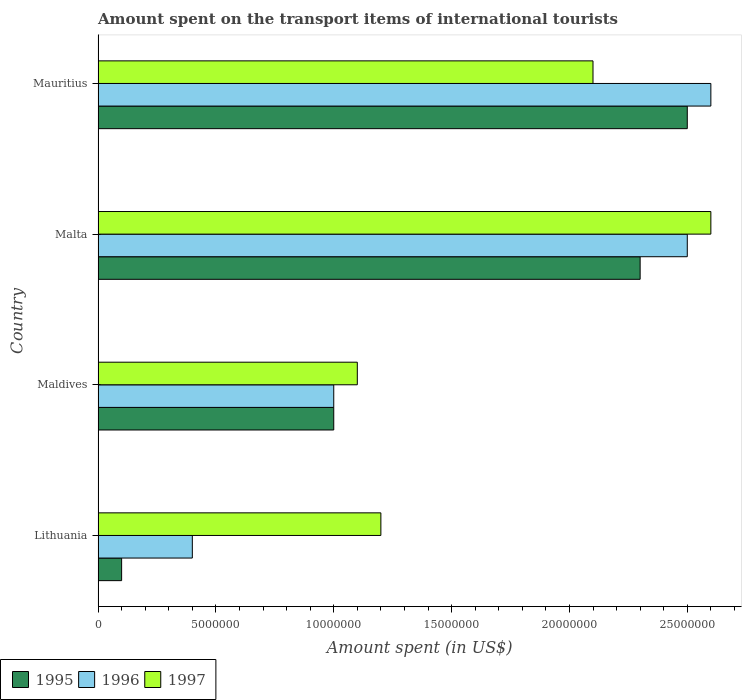How many bars are there on the 4th tick from the top?
Keep it short and to the point. 3. What is the label of the 3rd group of bars from the top?
Your answer should be very brief. Maldives. What is the amount spent on the transport items of international tourists in 1996 in Mauritius?
Offer a very short reply. 2.60e+07. Across all countries, what is the maximum amount spent on the transport items of international tourists in 1995?
Provide a succinct answer. 2.50e+07. In which country was the amount spent on the transport items of international tourists in 1996 maximum?
Keep it short and to the point. Mauritius. In which country was the amount spent on the transport items of international tourists in 1995 minimum?
Give a very brief answer. Lithuania. What is the total amount spent on the transport items of international tourists in 1995 in the graph?
Provide a short and direct response. 5.90e+07. What is the difference between the amount spent on the transport items of international tourists in 1996 in Lithuania and that in Maldives?
Make the answer very short. -6.00e+06. What is the difference between the amount spent on the transport items of international tourists in 1997 in Maldives and the amount spent on the transport items of international tourists in 1996 in Lithuania?
Provide a succinct answer. 7.00e+06. What is the average amount spent on the transport items of international tourists in 1996 per country?
Keep it short and to the point. 1.62e+07. In how many countries, is the amount spent on the transport items of international tourists in 1995 greater than 19000000 US$?
Offer a very short reply. 2. What is the ratio of the amount spent on the transport items of international tourists in 1996 in Maldives to that in Mauritius?
Your answer should be very brief. 0.38. What is the difference between the highest and the second highest amount spent on the transport items of international tourists in 1995?
Provide a succinct answer. 2.00e+06. What is the difference between the highest and the lowest amount spent on the transport items of international tourists in 1996?
Your answer should be compact. 2.20e+07. Is it the case that in every country, the sum of the amount spent on the transport items of international tourists in 1997 and amount spent on the transport items of international tourists in 1995 is greater than the amount spent on the transport items of international tourists in 1996?
Your response must be concise. Yes. Are all the bars in the graph horizontal?
Your answer should be very brief. Yes. How many countries are there in the graph?
Your answer should be compact. 4. Does the graph contain any zero values?
Offer a very short reply. No. Does the graph contain grids?
Your answer should be compact. No. Where does the legend appear in the graph?
Offer a terse response. Bottom left. How many legend labels are there?
Offer a very short reply. 3. What is the title of the graph?
Your answer should be compact. Amount spent on the transport items of international tourists. Does "2009" appear as one of the legend labels in the graph?
Ensure brevity in your answer.  No. What is the label or title of the X-axis?
Make the answer very short. Amount spent (in US$). What is the Amount spent (in US$) of 1996 in Lithuania?
Ensure brevity in your answer.  4.00e+06. What is the Amount spent (in US$) in 1997 in Lithuania?
Offer a very short reply. 1.20e+07. What is the Amount spent (in US$) of 1995 in Maldives?
Make the answer very short. 1.00e+07. What is the Amount spent (in US$) of 1996 in Maldives?
Offer a terse response. 1.00e+07. What is the Amount spent (in US$) in 1997 in Maldives?
Ensure brevity in your answer.  1.10e+07. What is the Amount spent (in US$) in 1995 in Malta?
Give a very brief answer. 2.30e+07. What is the Amount spent (in US$) in 1996 in Malta?
Offer a very short reply. 2.50e+07. What is the Amount spent (in US$) in 1997 in Malta?
Give a very brief answer. 2.60e+07. What is the Amount spent (in US$) of 1995 in Mauritius?
Make the answer very short. 2.50e+07. What is the Amount spent (in US$) in 1996 in Mauritius?
Provide a succinct answer. 2.60e+07. What is the Amount spent (in US$) in 1997 in Mauritius?
Ensure brevity in your answer.  2.10e+07. Across all countries, what is the maximum Amount spent (in US$) in 1995?
Keep it short and to the point. 2.50e+07. Across all countries, what is the maximum Amount spent (in US$) in 1996?
Keep it short and to the point. 2.60e+07. Across all countries, what is the maximum Amount spent (in US$) of 1997?
Offer a terse response. 2.60e+07. Across all countries, what is the minimum Amount spent (in US$) in 1995?
Provide a short and direct response. 1.00e+06. Across all countries, what is the minimum Amount spent (in US$) of 1996?
Your answer should be very brief. 4.00e+06. Across all countries, what is the minimum Amount spent (in US$) in 1997?
Your response must be concise. 1.10e+07. What is the total Amount spent (in US$) of 1995 in the graph?
Give a very brief answer. 5.90e+07. What is the total Amount spent (in US$) of 1996 in the graph?
Give a very brief answer. 6.50e+07. What is the total Amount spent (in US$) in 1997 in the graph?
Offer a terse response. 7.00e+07. What is the difference between the Amount spent (in US$) of 1995 in Lithuania and that in Maldives?
Give a very brief answer. -9.00e+06. What is the difference between the Amount spent (in US$) of 1996 in Lithuania and that in Maldives?
Make the answer very short. -6.00e+06. What is the difference between the Amount spent (in US$) in 1997 in Lithuania and that in Maldives?
Your answer should be very brief. 1.00e+06. What is the difference between the Amount spent (in US$) of 1995 in Lithuania and that in Malta?
Keep it short and to the point. -2.20e+07. What is the difference between the Amount spent (in US$) in 1996 in Lithuania and that in Malta?
Offer a very short reply. -2.10e+07. What is the difference between the Amount spent (in US$) in 1997 in Lithuania and that in Malta?
Ensure brevity in your answer.  -1.40e+07. What is the difference between the Amount spent (in US$) of 1995 in Lithuania and that in Mauritius?
Your answer should be compact. -2.40e+07. What is the difference between the Amount spent (in US$) in 1996 in Lithuania and that in Mauritius?
Offer a terse response. -2.20e+07. What is the difference between the Amount spent (in US$) in 1997 in Lithuania and that in Mauritius?
Give a very brief answer. -9.00e+06. What is the difference between the Amount spent (in US$) in 1995 in Maldives and that in Malta?
Your response must be concise. -1.30e+07. What is the difference between the Amount spent (in US$) in 1996 in Maldives and that in Malta?
Make the answer very short. -1.50e+07. What is the difference between the Amount spent (in US$) of 1997 in Maldives and that in Malta?
Your response must be concise. -1.50e+07. What is the difference between the Amount spent (in US$) in 1995 in Maldives and that in Mauritius?
Provide a short and direct response. -1.50e+07. What is the difference between the Amount spent (in US$) in 1996 in Maldives and that in Mauritius?
Keep it short and to the point. -1.60e+07. What is the difference between the Amount spent (in US$) in 1997 in Maldives and that in Mauritius?
Provide a short and direct response. -1.00e+07. What is the difference between the Amount spent (in US$) of 1995 in Malta and that in Mauritius?
Provide a succinct answer. -2.00e+06. What is the difference between the Amount spent (in US$) in 1996 in Malta and that in Mauritius?
Your response must be concise. -1.00e+06. What is the difference between the Amount spent (in US$) in 1995 in Lithuania and the Amount spent (in US$) in 1996 in Maldives?
Offer a very short reply. -9.00e+06. What is the difference between the Amount spent (in US$) of 1995 in Lithuania and the Amount spent (in US$) of 1997 in Maldives?
Make the answer very short. -1.00e+07. What is the difference between the Amount spent (in US$) in 1996 in Lithuania and the Amount spent (in US$) in 1997 in Maldives?
Provide a short and direct response. -7.00e+06. What is the difference between the Amount spent (in US$) in 1995 in Lithuania and the Amount spent (in US$) in 1996 in Malta?
Give a very brief answer. -2.40e+07. What is the difference between the Amount spent (in US$) of 1995 in Lithuania and the Amount spent (in US$) of 1997 in Malta?
Provide a short and direct response. -2.50e+07. What is the difference between the Amount spent (in US$) of 1996 in Lithuania and the Amount spent (in US$) of 1997 in Malta?
Provide a succinct answer. -2.20e+07. What is the difference between the Amount spent (in US$) in 1995 in Lithuania and the Amount spent (in US$) in 1996 in Mauritius?
Keep it short and to the point. -2.50e+07. What is the difference between the Amount spent (in US$) of 1995 in Lithuania and the Amount spent (in US$) of 1997 in Mauritius?
Make the answer very short. -2.00e+07. What is the difference between the Amount spent (in US$) of 1996 in Lithuania and the Amount spent (in US$) of 1997 in Mauritius?
Provide a succinct answer. -1.70e+07. What is the difference between the Amount spent (in US$) of 1995 in Maldives and the Amount spent (in US$) of 1996 in Malta?
Provide a succinct answer. -1.50e+07. What is the difference between the Amount spent (in US$) of 1995 in Maldives and the Amount spent (in US$) of 1997 in Malta?
Give a very brief answer. -1.60e+07. What is the difference between the Amount spent (in US$) in 1996 in Maldives and the Amount spent (in US$) in 1997 in Malta?
Provide a succinct answer. -1.60e+07. What is the difference between the Amount spent (in US$) of 1995 in Maldives and the Amount spent (in US$) of 1996 in Mauritius?
Make the answer very short. -1.60e+07. What is the difference between the Amount spent (in US$) of 1995 in Maldives and the Amount spent (in US$) of 1997 in Mauritius?
Your response must be concise. -1.10e+07. What is the difference between the Amount spent (in US$) in 1996 in Maldives and the Amount spent (in US$) in 1997 in Mauritius?
Your response must be concise. -1.10e+07. What is the difference between the Amount spent (in US$) of 1996 in Malta and the Amount spent (in US$) of 1997 in Mauritius?
Your response must be concise. 4.00e+06. What is the average Amount spent (in US$) in 1995 per country?
Your answer should be very brief. 1.48e+07. What is the average Amount spent (in US$) in 1996 per country?
Ensure brevity in your answer.  1.62e+07. What is the average Amount spent (in US$) in 1997 per country?
Make the answer very short. 1.75e+07. What is the difference between the Amount spent (in US$) in 1995 and Amount spent (in US$) in 1997 in Lithuania?
Give a very brief answer. -1.10e+07. What is the difference between the Amount spent (in US$) in 1996 and Amount spent (in US$) in 1997 in Lithuania?
Ensure brevity in your answer.  -8.00e+06. What is the difference between the Amount spent (in US$) of 1995 and Amount spent (in US$) of 1996 in Maldives?
Your answer should be very brief. 0. What is the difference between the Amount spent (in US$) in 1995 and Amount spent (in US$) in 1997 in Maldives?
Offer a very short reply. -1.00e+06. What is the difference between the Amount spent (in US$) of 1996 and Amount spent (in US$) of 1997 in Maldives?
Your response must be concise. -1.00e+06. What is the difference between the Amount spent (in US$) in 1995 and Amount spent (in US$) in 1996 in Malta?
Provide a short and direct response. -2.00e+06. What is the difference between the Amount spent (in US$) in 1996 and Amount spent (in US$) in 1997 in Malta?
Keep it short and to the point. -1.00e+06. What is the difference between the Amount spent (in US$) of 1995 and Amount spent (in US$) of 1996 in Mauritius?
Ensure brevity in your answer.  -1.00e+06. What is the ratio of the Amount spent (in US$) of 1995 in Lithuania to that in Malta?
Offer a very short reply. 0.04. What is the ratio of the Amount spent (in US$) in 1996 in Lithuania to that in Malta?
Offer a terse response. 0.16. What is the ratio of the Amount spent (in US$) in 1997 in Lithuania to that in Malta?
Offer a very short reply. 0.46. What is the ratio of the Amount spent (in US$) in 1996 in Lithuania to that in Mauritius?
Provide a succinct answer. 0.15. What is the ratio of the Amount spent (in US$) of 1995 in Maldives to that in Malta?
Offer a very short reply. 0.43. What is the ratio of the Amount spent (in US$) of 1997 in Maldives to that in Malta?
Offer a terse response. 0.42. What is the ratio of the Amount spent (in US$) in 1996 in Maldives to that in Mauritius?
Offer a very short reply. 0.38. What is the ratio of the Amount spent (in US$) of 1997 in Maldives to that in Mauritius?
Your answer should be compact. 0.52. What is the ratio of the Amount spent (in US$) of 1995 in Malta to that in Mauritius?
Offer a terse response. 0.92. What is the ratio of the Amount spent (in US$) in 1996 in Malta to that in Mauritius?
Provide a succinct answer. 0.96. What is the ratio of the Amount spent (in US$) in 1997 in Malta to that in Mauritius?
Your answer should be compact. 1.24. What is the difference between the highest and the second highest Amount spent (in US$) of 1995?
Your response must be concise. 2.00e+06. What is the difference between the highest and the second highest Amount spent (in US$) in 1996?
Provide a short and direct response. 1.00e+06. What is the difference between the highest and the lowest Amount spent (in US$) of 1995?
Keep it short and to the point. 2.40e+07. What is the difference between the highest and the lowest Amount spent (in US$) of 1996?
Ensure brevity in your answer.  2.20e+07. What is the difference between the highest and the lowest Amount spent (in US$) of 1997?
Offer a terse response. 1.50e+07. 